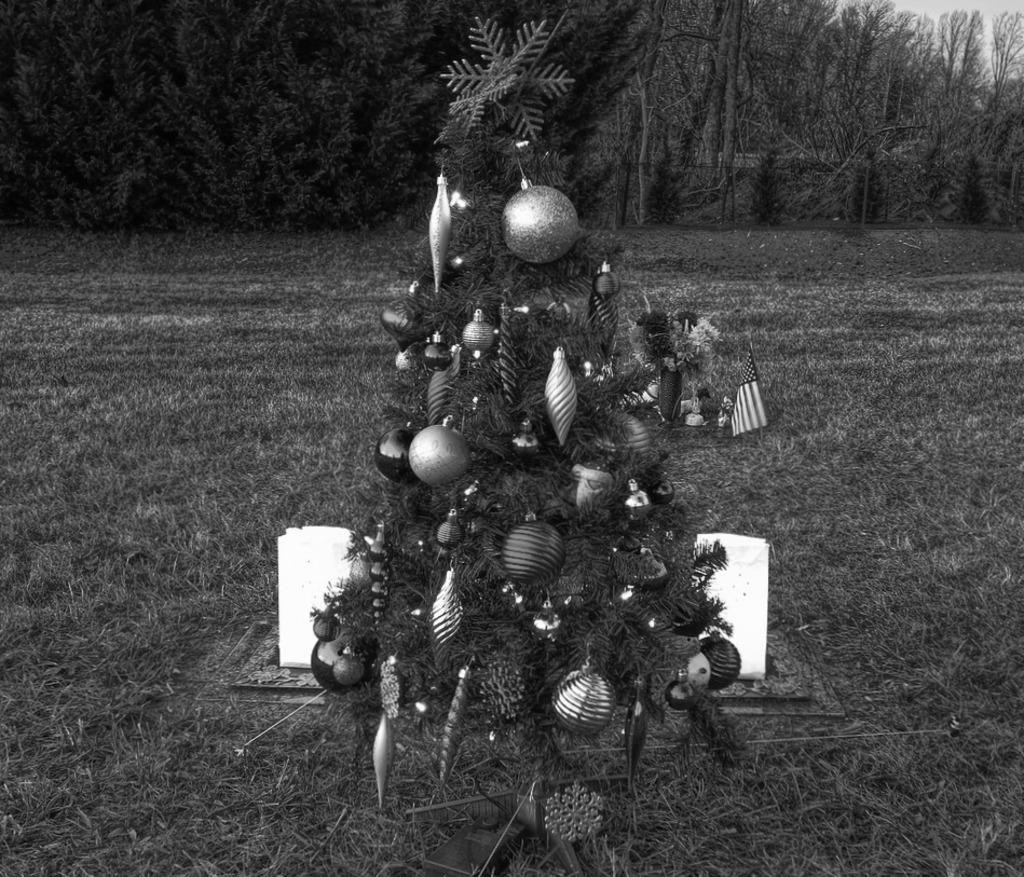What is the color scheme of the image? The image is in black and white. What is the main subject of the image? There is a Christmas tree in the image. Where is the Christmas tree located? The Christmas tree is on a grass field. What can be seen in the background of the image? There are many trees surrounding the Christmas tree. What type of mine is located near the Christmas tree in the image? There is no mine present in the image; it features a Christmas tree on a grass field surrounded by other trees. Can you tell me how many pencils are visible in the image? There are no pencils visible in the image; it features a Christmas tree and other trees on a grass field. 